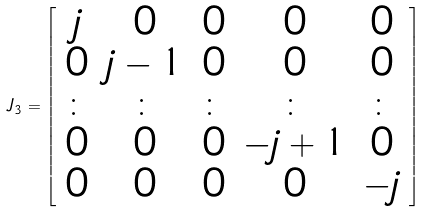<formula> <loc_0><loc_0><loc_500><loc_500>J _ { 3 } = \left [ \begin{array} [ c ] { c c c c c } j & 0 & 0 & 0 & 0 \\ 0 & j - 1 & 0 & 0 & 0 \\ \colon & \colon & \colon & \colon & \colon \\ 0 & 0 & 0 & - j + 1 & 0 \\ 0 & 0 & 0 & 0 & - j \end{array} \right ]</formula> 